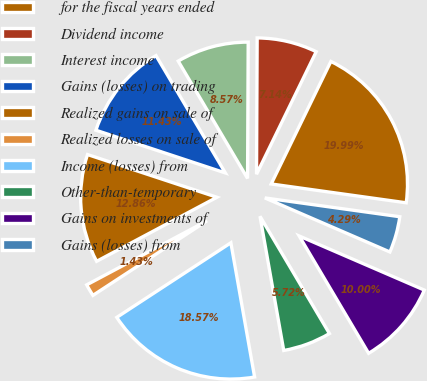Convert chart to OTSL. <chart><loc_0><loc_0><loc_500><loc_500><pie_chart><fcel>for the fiscal years ended<fcel>Dividend income<fcel>Interest income<fcel>Gains (losses) on trading<fcel>Realized gains on sale of<fcel>Realized losses on sale of<fcel>Income (losses) from<fcel>Other-than-temporary<fcel>Gains on investments of<fcel>Gains (losses) from<nl><fcel>19.99%<fcel>7.14%<fcel>8.57%<fcel>11.43%<fcel>12.86%<fcel>1.43%<fcel>18.57%<fcel>5.72%<fcel>10.0%<fcel>4.29%<nl></chart> 